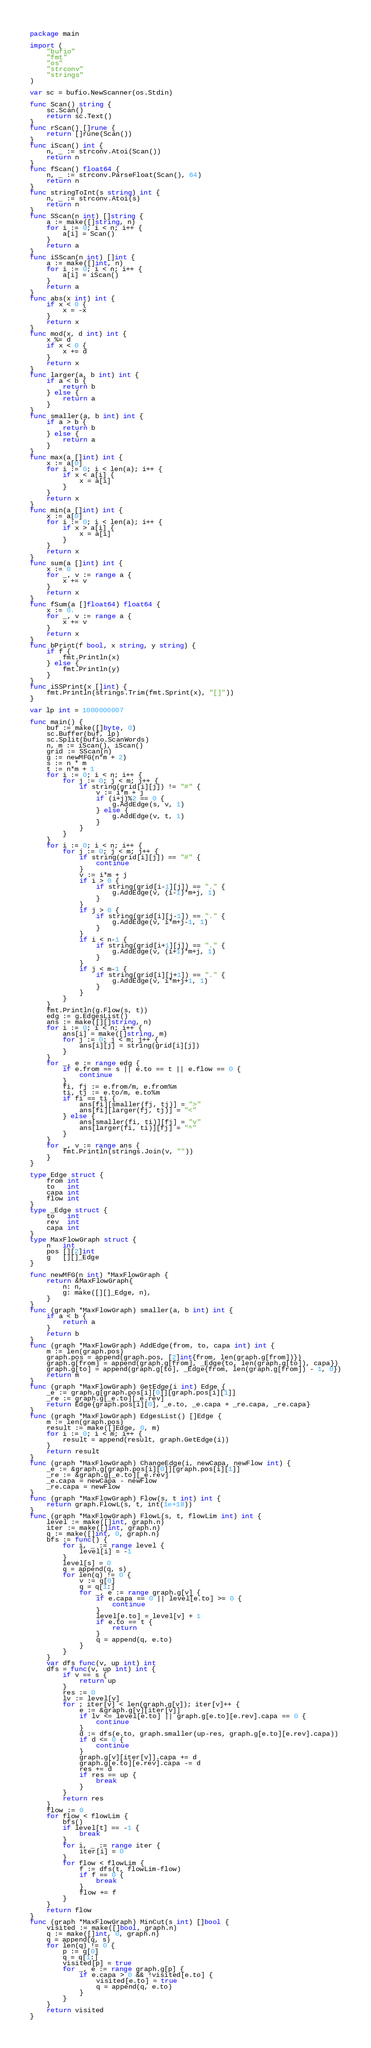Convert code to text. <code><loc_0><loc_0><loc_500><loc_500><_Go_>package main

import (
	"bufio"
	"fmt"
	"os"
	"strconv"
	"strings"
)

var sc = bufio.NewScanner(os.Stdin)

func Scan() string {
	sc.Scan()
	return sc.Text()
}
func rScan() []rune {
	return []rune(Scan())
}
func iScan() int {
	n, _ := strconv.Atoi(Scan())
	return n
}
func fScan() float64 {
	n, _ := strconv.ParseFloat(Scan(), 64)
	return n
}
func stringToInt(s string) int {
	n, _ := strconv.Atoi(s)
	return n
}
func SScan(n int) []string {
	a := make([]string, n)
	for i := 0; i < n; i++ {
		a[i] = Scan()
	}
	return a
}
func iSScan(n int) []int {
	a := make([]int, n)
	for i := 0; i < n; i++ {
		a[i] = iScan()
	}
	return a
}
func abs(x int) int {
	if x < 0 {
		x = -x
	}
	return x
}
func mod(x, d int) int {
	x %= d
	if x < 0 {
		x += d
	}
	return x
}
func larger(a, b int) int {
	if a < b {
		return b
	} else {
		return a
	}
}
func smaller(a, b int) int {
	if a > b {
		return b
	} else {
		return a
	}
}
func max(a []int) int {
	x := a[0]
	for i := 0; i < len(a); i++ {
		if x < a[i] {
			x = a[i]
		}
	}
	return x
}
func min(a []int) int {
	x := a[0]
	for i := 0; i < len(a); i++ {
		if x > a[i] {
			x = a[i]
		}
	}
	return x
}
func sum(a []int) int {
	x := 0
	for _, v := range a {
		x += v
	}
	return x
}
func fSum(a []float64) float64 {
	x := 0.
	for _, v := range a {
		x += v
	}
	return x
}
func bPrint(f bool, x string, y string) {
	if f {
		fmt.Println(x)
	} else {
		fmt.Println(y)
	}
}
func iSSPrint(x []int) {
	fmt.Println(strings.Trim(fmt.Sprint(x), "[]"))
}

var lp int = 1000000007

func main() {
	buf := make([]byte, 0)
	sc.Buffer(buf, lp)
	sc.Split(bufio.ScanWords)
	n, m := iScan(), iScan()
	grid := SScan(n)
	g := newMFG(n*m + 2)
	s := n * m
	t := n*m + 1
	for i := 0; i < n; i++ {
		for j := 0; j < m; j++ {
			if string(grid[i][j]) != "#" {
				v := i*m + j
				if (i+j)%2 == 0 {
					g.AddEdge(s, v, 1)
				} else {
					g.AddEdge(v, t, 1)
				}
			}
		}
	}
	for i := 0; i < n; i++ {
		for j := 0; j < m; j++ {
			if string(grid[i][j]) == "#" {
				continue
			}
			v := i*m + j
			if i > 0 {
				if string(grid[i-1][j]) == "." {
					g.AddEdge(v, (i-1)*m+j, 1)
				}
			}
			if j > 0 {
				if string(grid[i][j-1]) == "." {
					g.AddEdge(v, i*m+j-1, 1)
				}
			}
			if i < n-1 {
				if string(grid[i+1][j]) == "." {
					g.AddEdge(v, (i+1)*m+j, 1)
				}
			}
			if j < m-1 {
				if string(grid[i][j+1]) == "." {
					g.AddEdge(v, i*m+j+1, 1)
				}
			}
		}
	}
	fmt.Println(g.Flow(s, t))
	edg := g.EdgesList()
	ans := make([][]string, n)
	for i := 0; i < n; i++ {
		ans[i] = make([]string, m)
		for j := 0; j < m; j++ {
			ans[i][j] = string(grid[i][j])
		}
	}
	for _, e := range edg {
		if e.from == s || e.to == t || e.flow == 0 {
			continue
		}
		fi, fj := e.from/m, e.from%m
		ti, tj := e.to/m, e.to%m
		if fi == ti {
			ans[fi][smaller(fj, tj)] = ">"
			ans[fi][larger(fj, tj)] = "<"
		} else {
			ans[smaller(fi, ti)][fj] = "v"
			ans[larger(fi, ti)][fj] = "^"
		}
	}
	for _, v := range ans {
		fmt.Println(strings.Join(v, ""))
	}
}

type Edge struct {
	from int
	to   int
	capa int
	flow int
}
type _Edge struct {
	to   int
	rev  int
	capa int
}
type MaxFlowGraph struct {
	n   int
	pos [][2]int
	g   [][]_Edge
}

func newMFG(n int) *MaxFlowGraph {
	return &MaxFlowGraph{
		n: n,
		g: make([][]_Edge, n),
	}
}
func (graph *MaxFlowGraph) smaller(a, b int) int {
	if a < b {
		return a
	}
	return b
}
func (graph *MaxFlowGraph) AddEdge(from, to, capa int) int {
	m := len(graph.pos)
	graph.pos = append(graph.pos, [2]int{from, len(graph.g[from])})
	graph.g[from] = append(graph.g[from], _Edge{to, len(graph.g[to]), capa})
	graph.g[to] = append(graph.g[to], _Edge{from, len(graph.g[from]) - 1, 0})
	return m
}
func (graph *MaxFlowGraph) GetEdge(i int) Edge {
	_e := graph.g[graph.pos[i][0]][graph.pos[i][1]]
	_re := graph.g[_e.to][_e.rev]
	return Edge{graph.pos[i][0], _e.to, _e.capa + _re.capa, _re.capa}
}
func (graph *MaxFlowGraph) EdgesList() []Edge {
	m := len(graph.pos)
	result := make([]Edge, 0, m)
	for i := 0; i < m; i++ {
		result = append(result, graph.GetEdge(i))
	}
	return result
}
func (graph *MaxFlowGraph) ChangeEdge(i, newCapa, newFlow int) {
	_e := &graph.g[graph.pos[i][0]][graph.pos[i][1]]
	_re := &graph.g[_e.to][_e.rev]
	_e.capa = newCapa - newFlow
	_re.capa = newFlow
}
func (graph *MaxFlowGraph) Flow(s, t int) int {
	return graph.FlowL(s, t, int(1e+18))
}
func (graph *MaxFlowGraph) FlowL(s, t, flowLim int) int {
	level := make([]int, graph.n)
	iter := make([]int, graph.n)
	q := make([]int, 0, graph.n)
	bfs := func() {
		for i, _ := range level {
			level[i] = -1
		}
		level[s] = 0
		q = append(q, s)
		for len(q) != 0 {
			v := q[0]
			q = q[1:]
			for _, e := range graph.g[v] {
				if e.capa == 0 || level[e.to] >= 0 {
					continue
				}
				level[e.to] = level[v] + 1
				if e.to == t {
					return
				}
				q = append(q, e.to)
			}
		}
	}
	var dfs func(v, up int) int
	dfs = func(v, up int) int {
		if v == s {
			return up
		}
		res := 0
		lv := level[v]
		for ; iter[v] < len(graph.g[v]); iter[v]++ {
			e := &graph.g[v][iter[v]]
			if lv <= level[e.to] || graph.g[e.to][e.rev].capa == 0 {
				continue
			}
			d := dfs(e.to, graph.smaller(up-res, graph.g[e.to][e.rev].capa))
			if d <= 0 {
				continue
			}
			graph.g[v][iter[v]].capa += d
			graph.g[e.to][e.rev].capa -= d
			res += d
			if res == up {
				break
			}
		}
		return res
	}
	flow := 0
	for flow < flowLim {
		bfs()
		if level[t] == -1 {
			break
		}
		for i, _ := range iter {
			iter[i] = 0
		}
		for flow < flowLim {
			f := dfs(t, flowLim-flow)
			if f == 0 {
				break
			}
			flow += f
		}
	}
	return flow
}
func (graph *MaxFlowGraph) MinCut(s int) []bool {
	visited := make([]bool, graph.n)
	q := make([]int, 0, graph.n)
	q = append(q, s)
	for len(q) != 0 {
		p := q[0]
		q = q[1:]
		visited[p] = true
		for _, e := range graph.g[p] {
			if e.capa > 0 && !visited[e.to] {
				visited[e.to] = true
				q = append(q, e.to)
			}
		}
	}
	return visited
}
</code> 